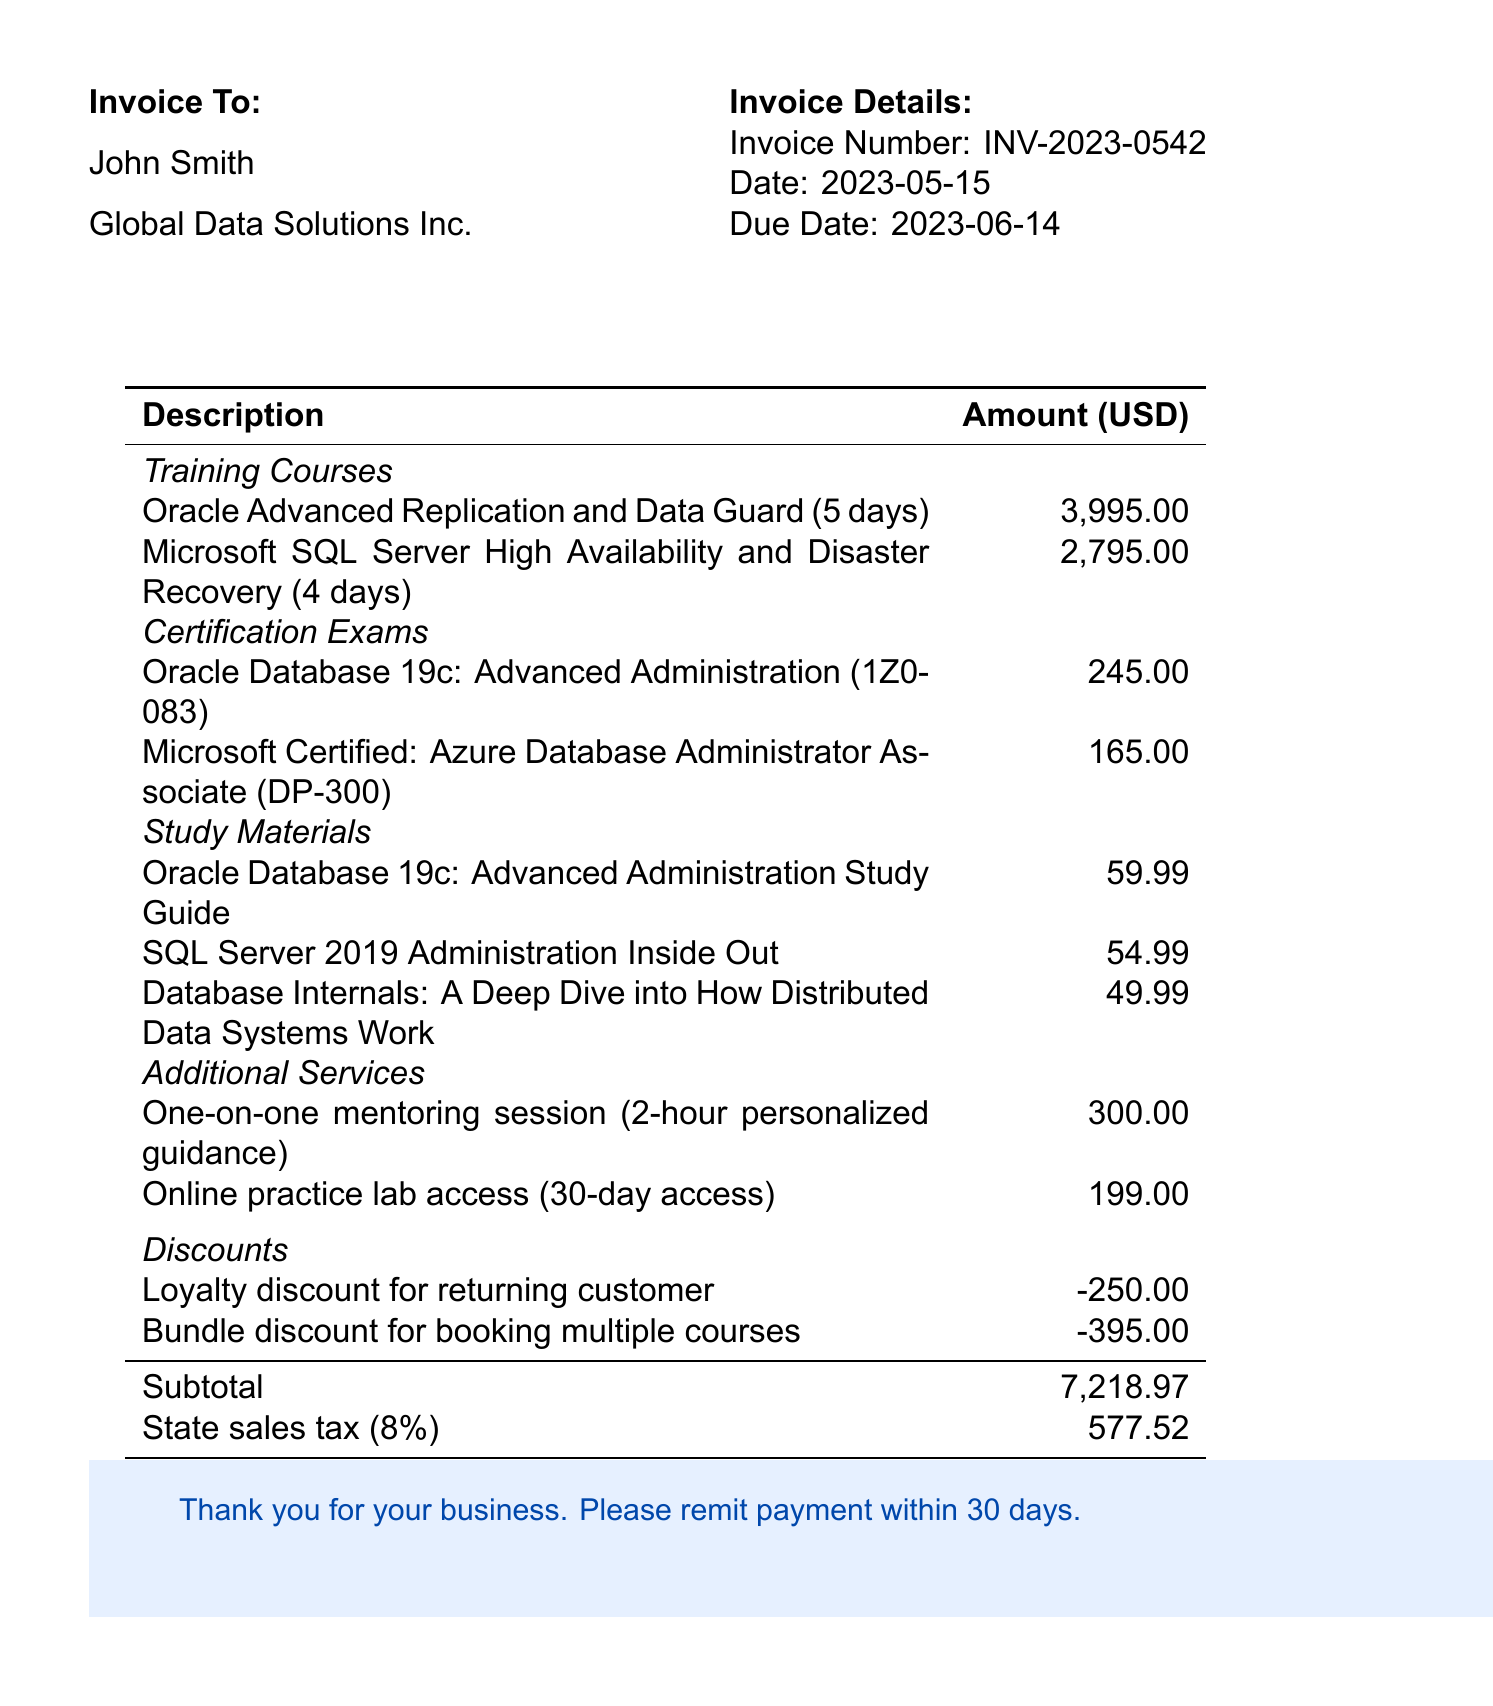what is the invoice number? The invoice number is directly stated in the invoice details section.
Answer: INV-2023-0542 who is the client? The client's name is provided in the invoice section as the recipient of the invoice.
Answer: John Smith what is the price of the Microsoft training course? The price of the Microsoft SQL Server High Availability and Disaster Recovery training course is listed in the training courses section.
Answer: 2795.00 how many days is the Oracle training course? The duration of the Oracle Advanced Replication and Data Guard course is specified in the training courses section.
Answer: 5 days what is the total due amount? The total amount due is provided at the bottom of the invoice, after calculating all items, discounts, and taxes.
Answer: 7796.49 what is the discount amount for returning customers? The invoice lists specific discounts for various reasons, including loyalty discounts.
Answer: -250.00 what type of study material is "Database Internals"? The invoice details list various study materials along with their types, providing context for each material.
Answer: Book how many hours does the mentoring session last? The duration of the mentoring session is mentioned in the additional services section.
Answer: 2-hour what is the tax rate applicable to this invoice? The document specifies the tax rate applicable to the total amount due, detailing the tax calculation applied.
Answer: 8% 